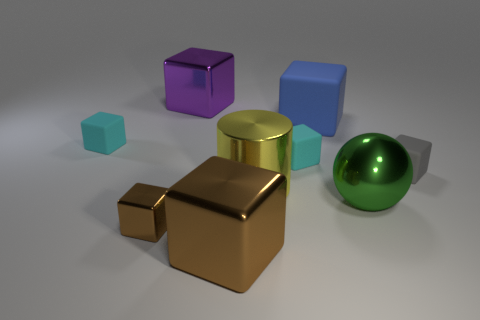Subtract all brown cylinders. How many cyan cubes are left? 2 Subtract all big shiny blocks. How many blocks are left? 5 Subtract all blue blocks. How many blocks are left? 6 Subtract all cubes. How many objects are left? 2 Subtract all brown blocks. Subtract all green spheres. How many blocks are left? 5 Subtract all small cyan blocks. Subtract all cyan objects. How many objects are left? 5 Add 2 matte blocks. How many matte blocks are left? 6 Add 9 blue cylinders. How many blue cylinders exist? 9 Subtract 0 cyan cylinders. How many objects are left? 9 